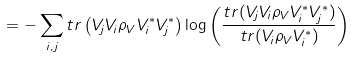<formula> <loc_0><loc_0><loc_500><loc_500>= - \sum _ { i , j } t r \left ( V _ { j } V _ { i } \rho _ { V } V _ { i } ^ { * } V _ { j } ^ { * } \right ) \log { \left ( \frac { t r ( V _ { j } V _ { i } \rho _ { V } V _ { i } ^ { * } V _ { j } ^ { * } ) } { t r ( V _ { i } \rho _ { V } V _ { i } ^ { * } ) } \right ) }</formula> 